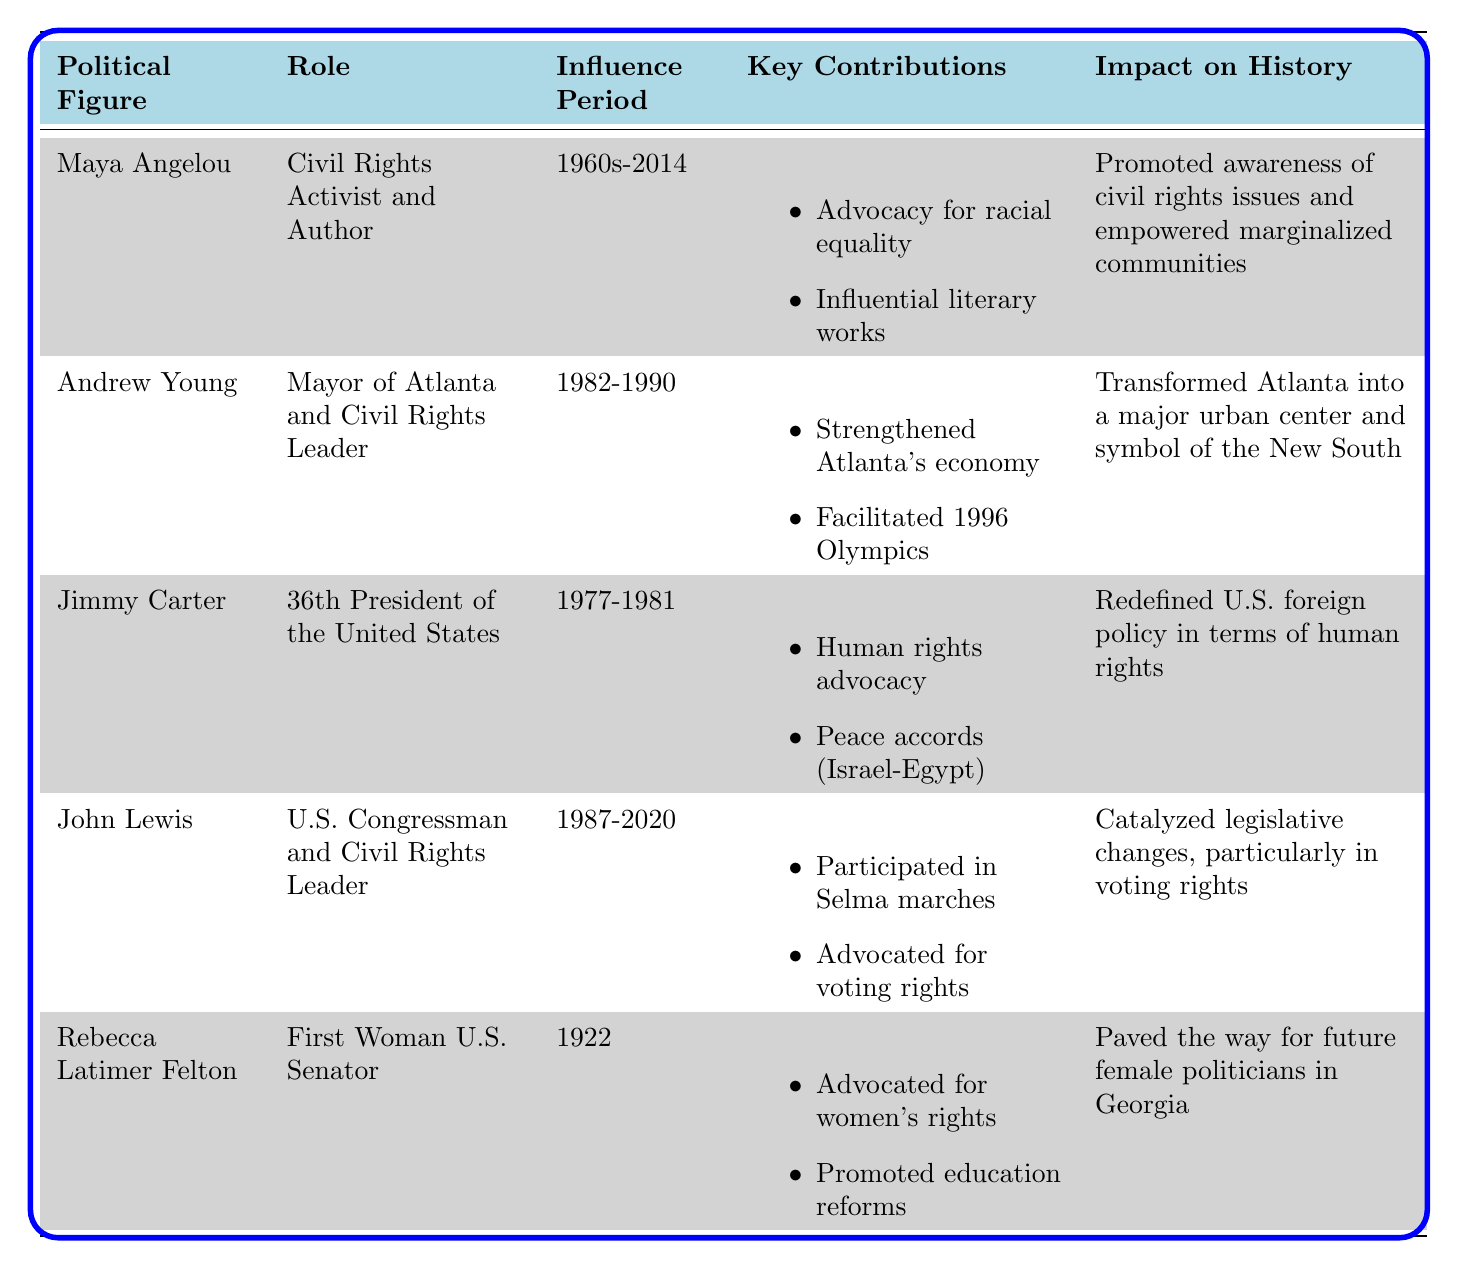What role did Maya Angelou play in local politics? Maya Angelou is identified as a Civil Rights Activist and Author in the table.
Answer: Civil Rights Activist and Author What years did Andrew Young serve as Mayor of Atlanta? Andrew Young's influence period is listed as 1982-1990.
Answer: 1982-1990 True or False: Jimmy Carter was involved in human rights advocacy. The table lists "Human rights advocacy" as one of Jimmy Carter's key contributions, confirming his involvement in this area.
Answer: True What impact did John Lewis have on voting rights? The table states that John Lewis "catalyzed legislative changes, particularly in voting rights" as his impact on history.
Answer: Catalyzed legislative changes in voting rights Which political figure was the first woman U.S. Senator from Georgia? The table directly names Rebecca Latimer Felton as the "First Woman U.S. Senator" in the relevant row.
Answer: Rebecca Latimer Felton What were the key contributions of Andrew Young regarding the 1996 Summer Olympics? The table indicates that Andrew Young "Facilitated the 1996 Summer Olympics in Atlanta" as a key contribution but does not provide specific details about those contributions.
Answer: Facilitated the 1996 Summer Olympics in Atlanta Calculate the total number of years that Maya Angelou and John Lewis influenced local politics. Maya Angelou influenced from the 1960s to 2014, which can be estimated as around 44 years (1960 - 2014), while John Lewis influenced from 1987 to 2020, which is 33 years (1987 - 2020). Adding these gives 44 + 33 = 77 years.
Answer: 77 years True or False: Rebecca Latimer Felton's contributions were solely focused on women's rights. The table lists her contributions as including advocacy for women's rights and promoting education and agricultural reforms, indicating she had a broader focus.
Answer: False What major transformation is associated with Andrew Young's tenure as Mayor of Atlanta? The table states that Andrew Young "transformed Atlanta into a major urban center and symbol of the New South," indicating significant urban development during his tenure.
Answer: Transformed Atlanta into a major urban center 